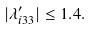<formula> <loc_0><loc_0><loc_500><loc_500>| \lambda ^ { \prime } _ { i 3 3 } | \leq 1 . 4 .</formula> 